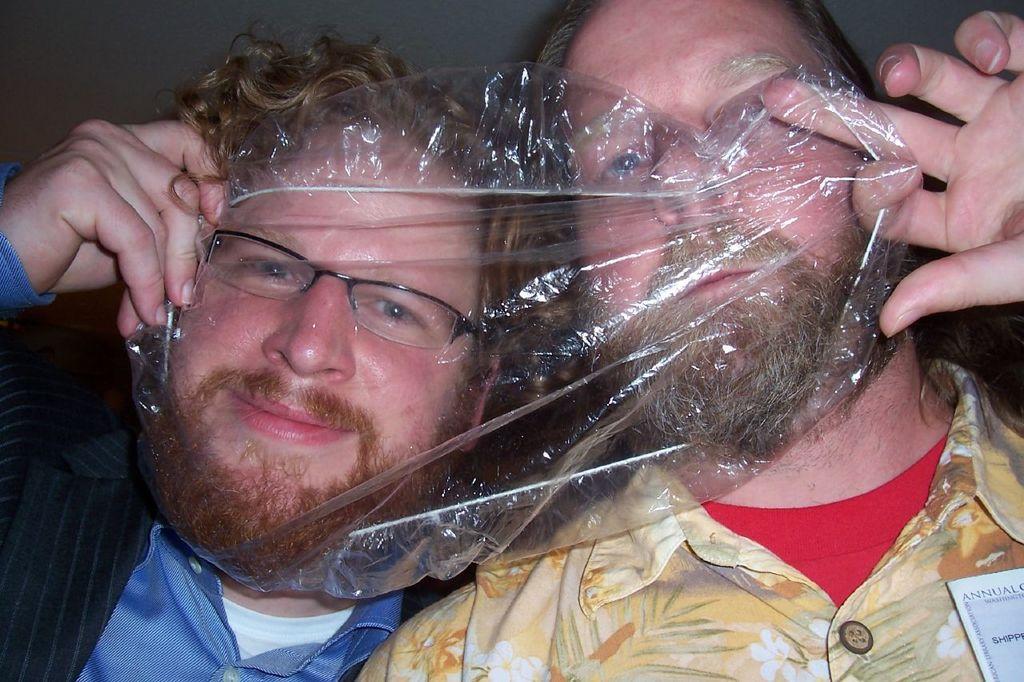How would you summarize this image in a sentence or two? In the image there are two men in the foreground, they are covering their face with a plastic sheet. 